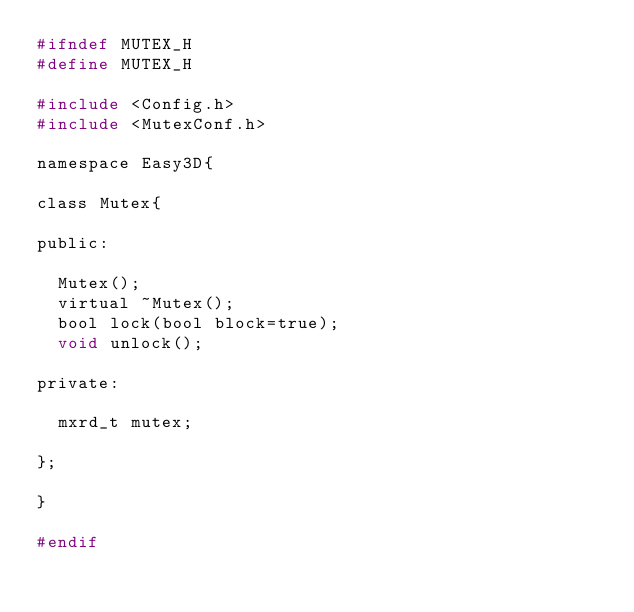Convert code to text. <code><loc_0><loc_0><loc_500><loc_500><_C_>#ifndef MUTEX_H
#define MUTEX_H

#include <Config.h>
#include <MutexConf.h>

namespace Easy3D{
    
class Mutex{

public:

	Mutex();
	virtual ~Mutex();
	bool lock(bool block=true);
	void unlock();

private:

	mxrd_t mutex;

};
    
}

#endif</code> 